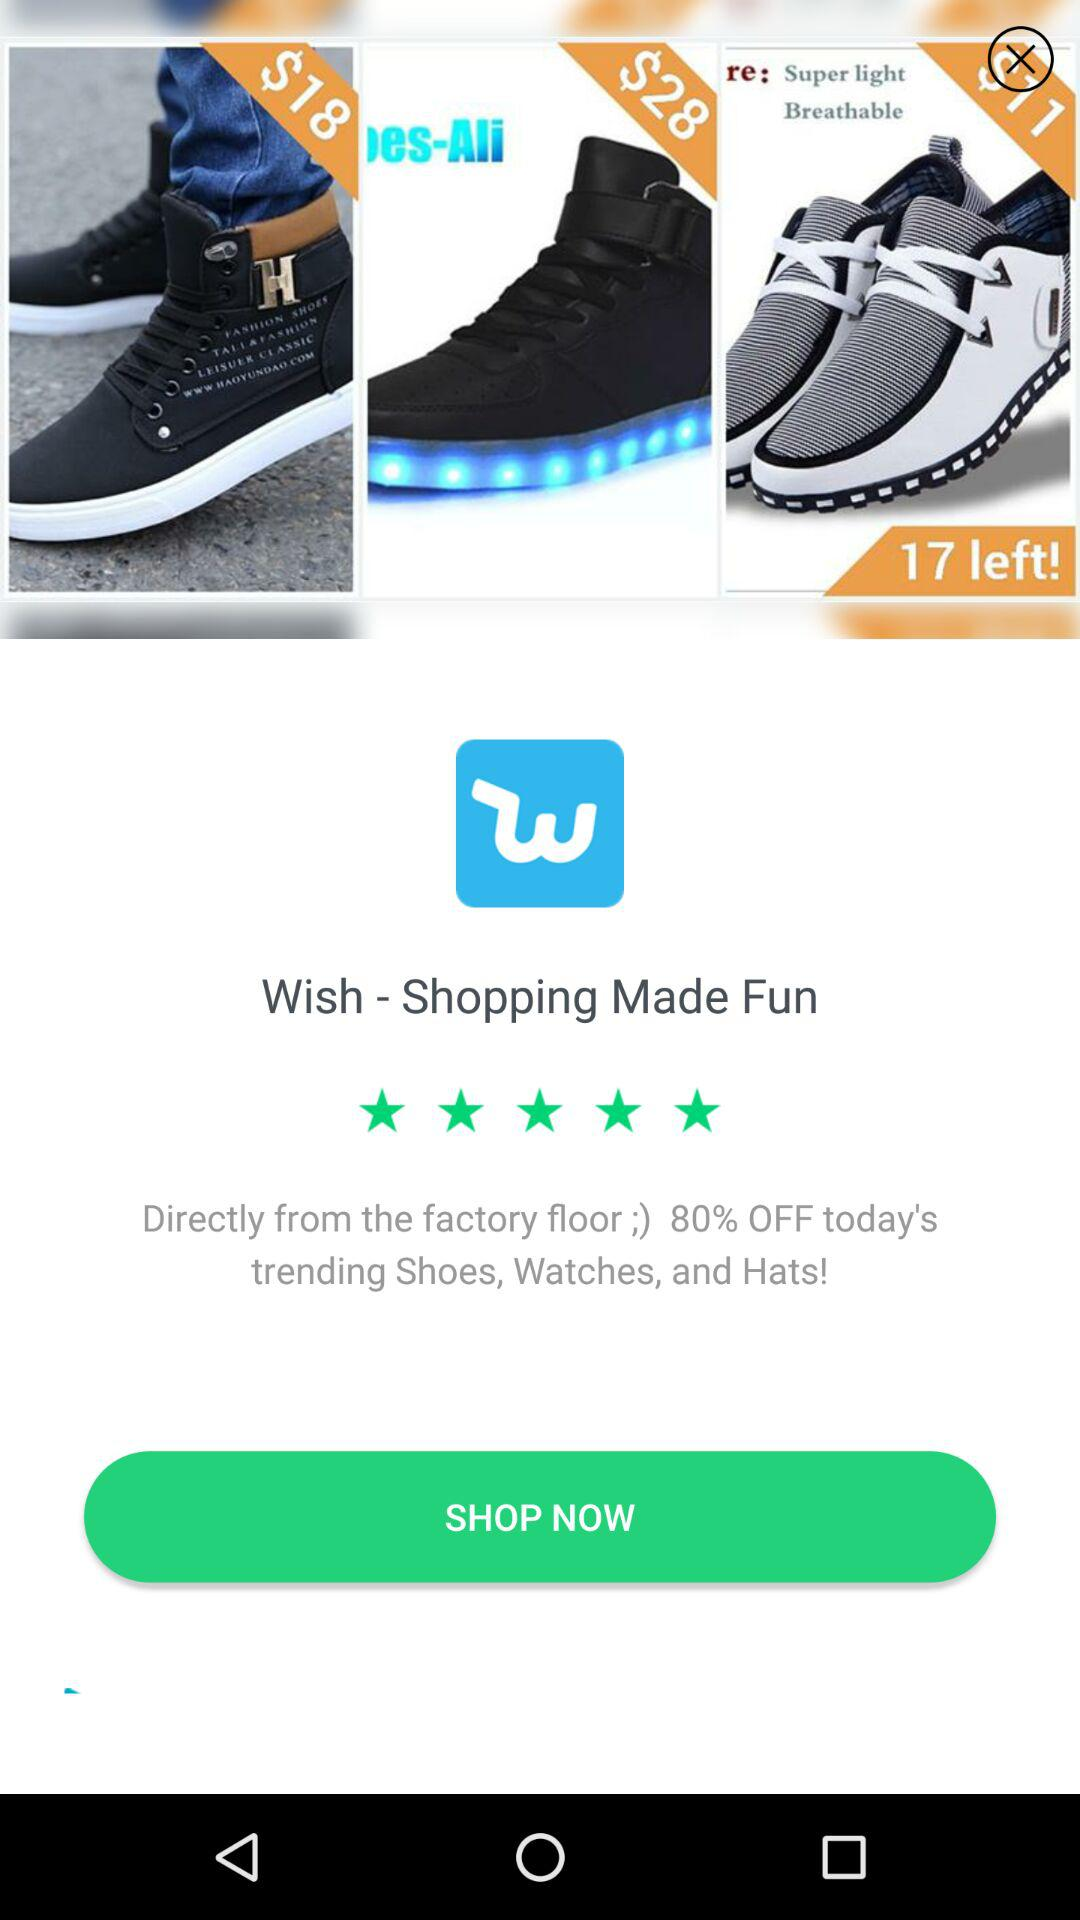What is the rating of the application out of 5? The rating of the application is 5 out of 5 stars. 